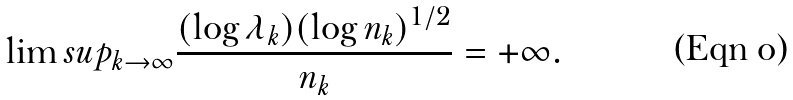<formula> <loc_0><loc_0><loc_500><loc_500>\lim s u p _ { k \to \infty } \frac { ( \log \lambda _ { k } ) ( \log n _ { k } ) ^ { 1 / 2 } } { n _ { k } } = + \infty .</formula> 